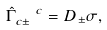Convert formula to latex. <formula><loc_0><loc_0><loc_500><loc_500>\hat { \Gamma } _ { c \pm } ^ { \ \ c } = D _ { \pm } \sigma ,</formula> 